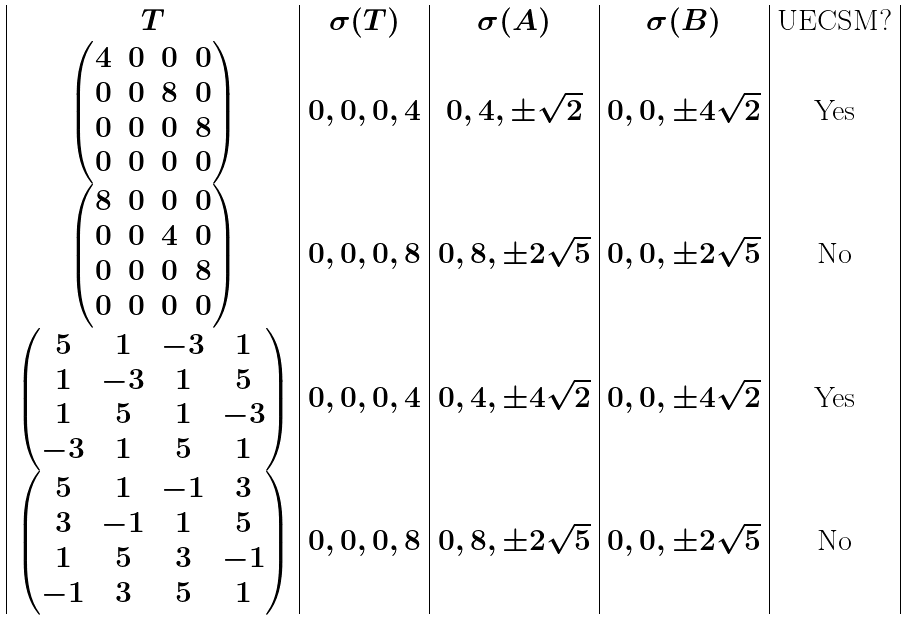Convert formula to latex. <formula><loc_0><loc_0><loc_500><loc_500>\begin{array} { | c | c | c | c | c | } T & \sigma ( T ) & \sigma ( A ) & \sigma ( B ) & \text {UECSM?} \\ \begin{pmatrix} 4 & 0 & 0 & 0 \\ 0 & 0 & 8 & 0 \\ 0 & 0 & 0 & 8 \\ 0 & 0 & 0 & 0 \\ \end{pmatrix} & 0 , 0 , 0 , 4 & 0 , 4 , \pm \sqrt { 2 } & 0 , 0 , \pm 4 \sqrt { 2 } & \text {Yes} \\ \begin{pmatrix} 8 & 0 & 0 & 0 \\ 0 & 0 & 4 & 0 \\ 0 & 0 & 0 & 8 \\ 0 & 0 & 0 & 0 \\ \end{pmatrix} & 0 , 0 , 0 , 8 & 0 , 8 , \pm 2 \sqrt { 5 } & 0 , 0 , \pm 2 \sqrt { 5 } & \text {No} \\ \begin{pmatrix} 5 & 1 & - 3 & 1 \\ 1 & - 3 & 1 & 5 \\ 1 & 5 & 1 & - 3 \\ - 3 & 1 & 5 & 1 \end{pmatrix} & 0 , 0 , 0 , 4 & 0 , 4 , \pm 4 \sqrt { 2 } & 0 , 0 , \pm 4 \sqrt { 2 } & \text {Yes} \\ \begin{pmatrix} 5 & 1 & - 1 & 3 \\ 3 & - 1 & 1 & 5 \\ 1 & 5 & 3 & - 1 \\ - 1 & 3 & 5 & 1 \end{pmatrix} & 0 , 0 , 0 , 8 & 0 , 8 , \pm 2 \sqrt { 5 } & 0 , 0 , \pm 2 \sqrt { 5 } & \text {No} \\ \end{array}</formula> 